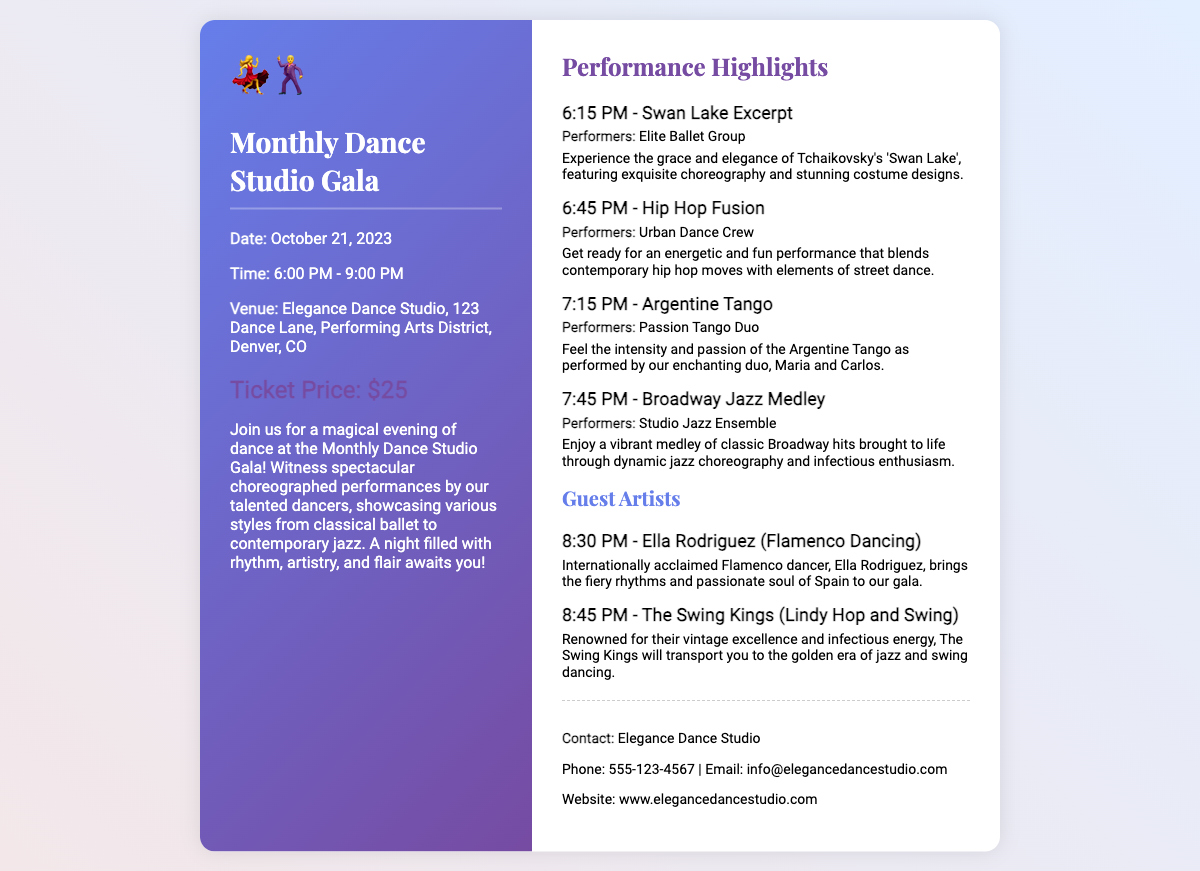What is the date of the event? The date of the event is mentioned in the document as October 21, 2023.
Answer: October 21, 2023 What is the ticket price? The document specifies the ticket price as $25.
Answer: $25 What venue is hosting the gala? The venue for the gala is provided in the document as Elegance Dance Studio.
Answer: Elegance Dance Studio Which group performs the Argentine Tango? The document lists the performing duo for the Argentine Tango as Passion Tango Duo.
Answer: Passion Tango Duo How long does the event last? The document states the event runs from 6:00 PM to 9:00 PM, indicating a duration of 3 hours.
Answer: 3 hours What does Ella Rodriguez perform? The document notes that Ella Rodriguez performs Flamenco Dancing as a guest artist.
Answer: Flamenco Dancing How many performances are scheduled before the guest artists? The document outlines four performances scheduled before the guest artists appear.
Answer: Four What is the contact email for the dance studio? The document includes the contact email as info@elegancedancestudio.com.
Answer: info@elegancedancestudio.com 